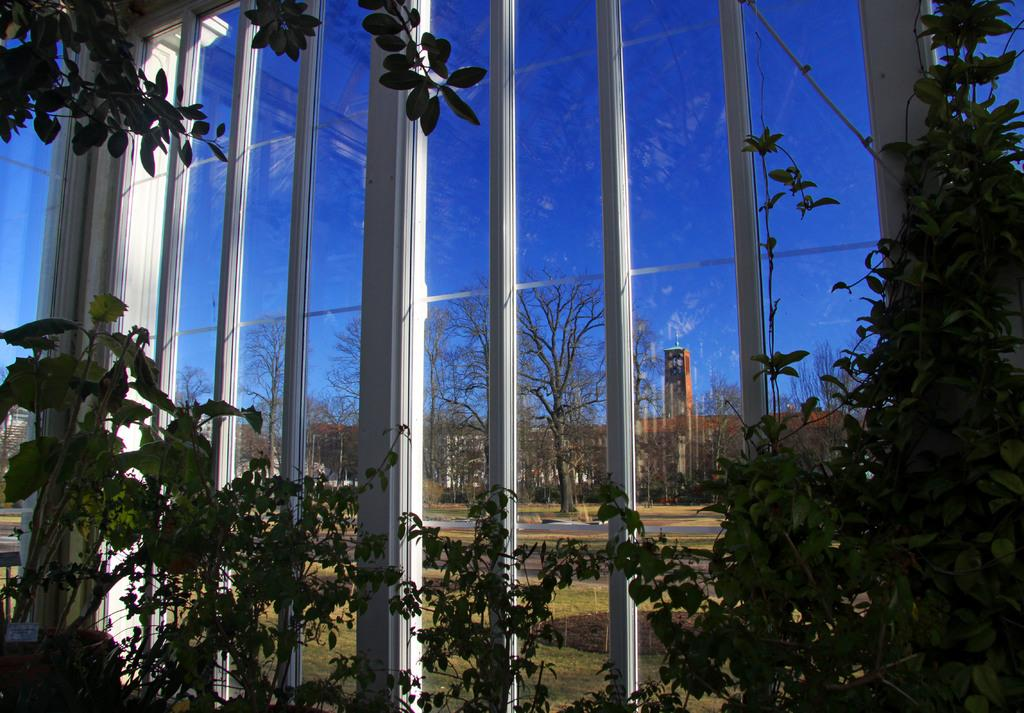What type of plants are located at the bottom of the image? There are potted plants at the bottom of the image. What is the material of the walls behind the potted plants? The walls behind the potted plants are made of glass. What can be seen through the glass walls? Trees are visible through the glass walls. What structures are visible behind the trees? There are buildings visible behind the trees. What part of the natural environment is visible in the image? The sky is visible in the image. What type of apple can be smelled in the image? There is no apple present in the image, and therefore no smell can be associated with it. Can you describe the fish swimming in the potted plants? There are no fish present in the image; it features potted plants, glass walls, trees, buildings, and the sky. 